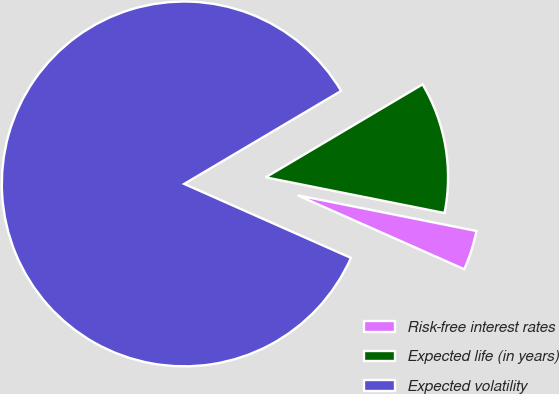<chart> <loc_0><loc_0><loc_500><loc_500><pie_chart><fcel>Risk-free interest rates<fcel>Expected life (in years)<fcel>Expected volatility<nl><fcel>3.51%<fcel>11.65%<fcel>84.84%<nl></chart> 